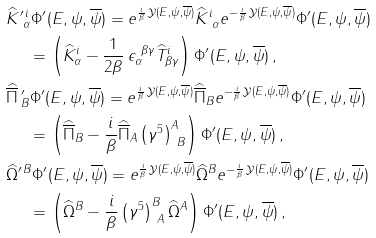<formula> <loc_0><loc_0><loc_500><loc_500>& \widehat { K } ^ { \prime \, i } _ { \ \alpha } \Phi ^ { \prime } ( E , \psi , \overline { \psi } ) = e ^ { \frac { i } { \beta } \, \mathcal { Y } ( E , \psi , \overline { \psi } ) } \widehat { K } ^ { i } _ { \ \alpha } e ^ { - \frac { i } { \beta } \, \mathcal { Y } ( E , \psi , \overline { \psi } ) } \Phi ^ { \prime } ( E , \psi , \overline { \psi } ) \\ & \quad \ = \left ( \widehat { K } ^ { i } _ { \alpha } - \frac { 1 } { 2 \beta } \, \epsilon ^ { \ \beta \gamma } _ { \alpha } \widehat { T } ^ { i } _ { \beta \gamma } \right ) \Phi ^ { \prime } ( E , \psi , \overline { \psi } ) \, , \\ & \widehat { \overline { \Pi } } \, ^ { \prime } _ { B } \Phi ^ { \prime } ( E , \psi , \overline { \psi } ) = e ^ { \frac { i } { \beta } \, \mathcal { Y } ( E , \psi , \overline { \psi } ) } \widehat { \overline { \Pi } } _ { B } e ^ { - \frac { i } { \beta } \, \mathcal { Y } ( E , \psi , \overline { \psi } ) } \Phi ^ { \prime } ( E , \psi , \overline { \psi } ) \\ & \quad \ = \left ( \widehat { \overline { \Pi } } _ { B } - \frac { i } { \beta } \widehat { \overline { \Pi } } _ { A } \left ( \gamma ^ { 5 } \right ) ^ { A } _ { \ B } \right ) \Phi ^ { \prime } ( E , \psi , \overline { \psi } ) \, , \\ & \widehat { \Omega } ^ { \prime \, B } \Phi ^ { \prime } ( E , \psi , \overline { \psi } ) = e ^ { \frac { i } { \beta } \, \mathcal { Y } ( E , \psi , \overline { \psi } ) } \widehat { \Omega } ^ { B } e ^ { - \frac { i } { \beta } \, \mathcal { Y } ( E , \psi , \overline { \psi } ) } \Phi ^ { \prime } ( E , \psi , \overline { \psi } ) \\ & \quad \ = \left ( \widehat { \Omega } ^ { B } - \frac { i } { \beta } \left ( \gamma ^ { 5 } \right ) ^ { B } _ { \ A } \widehat { \Omega } ^ { A } \right ) \Phi ^ { \prime } ( E , \psi , \overline { \psi } ) \, ,</formula> 